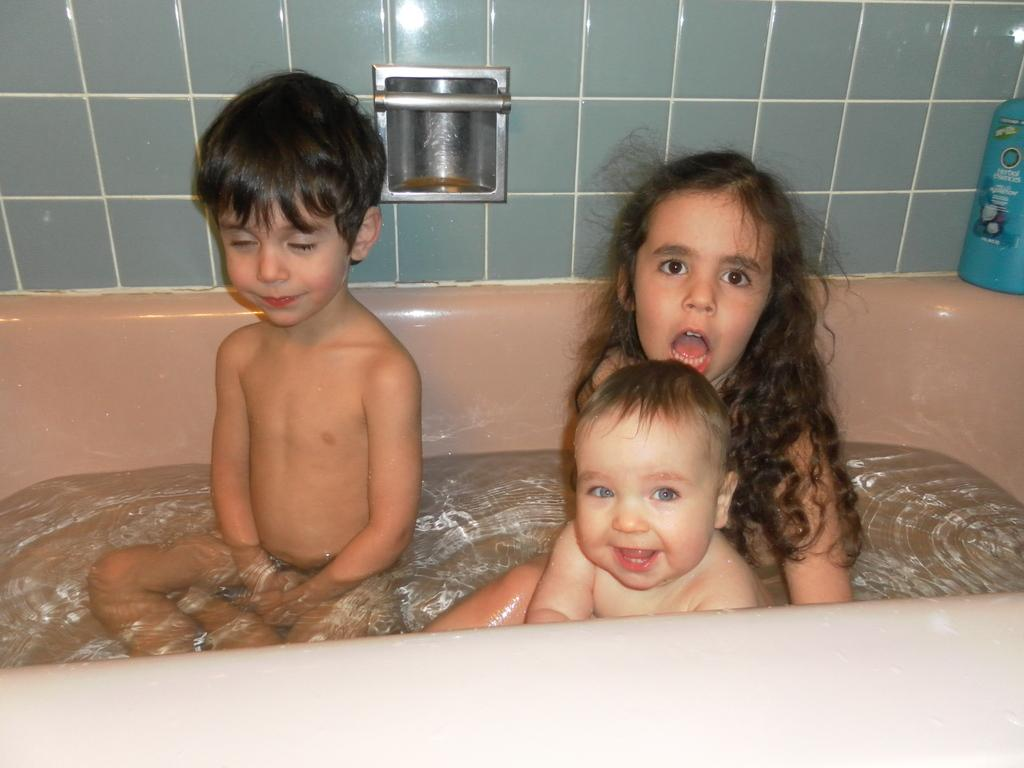What are the children doing in the image? The children are in the bathtub. What can be seen in the background of the image? There is a wall in the background of the image. What is the color of the bottle on the right side of the image? The bottle is blue. What title does the beggar have in the image? There is no beggar present in the image. What type of flight is depicted in the image? There is no flight depicted in the image. 